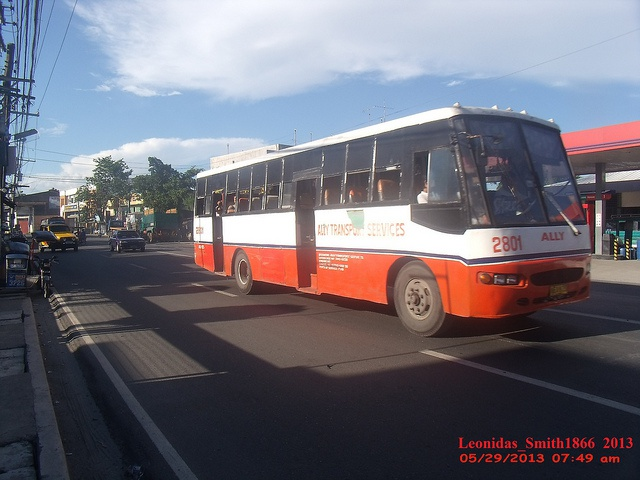Describe the objects in this image and their specific colors. I can see bus in blue, gray, white, black, and maroon tones, people in blue, black, and gray tones, truck in blue, black, gray, and olive tones, car in blue, black, gray, and darkgray tones, and motorcycle in blue, black, gray, and darkgray tones in this image. 